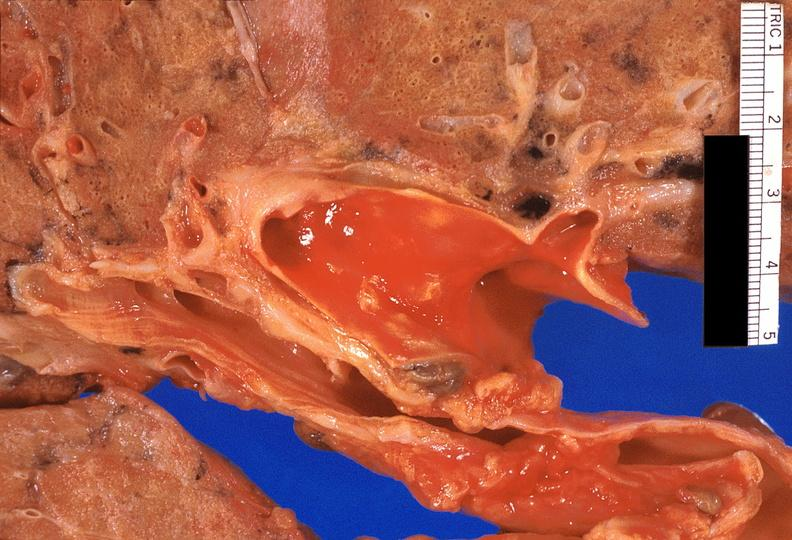where is this?
Answer the question using a single word or phrase. Lung 